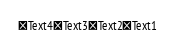<code> <loc_0><loc_0><loc_500><loc_500><_VisualBasic_>Text4Text3Text2Text1</code> 